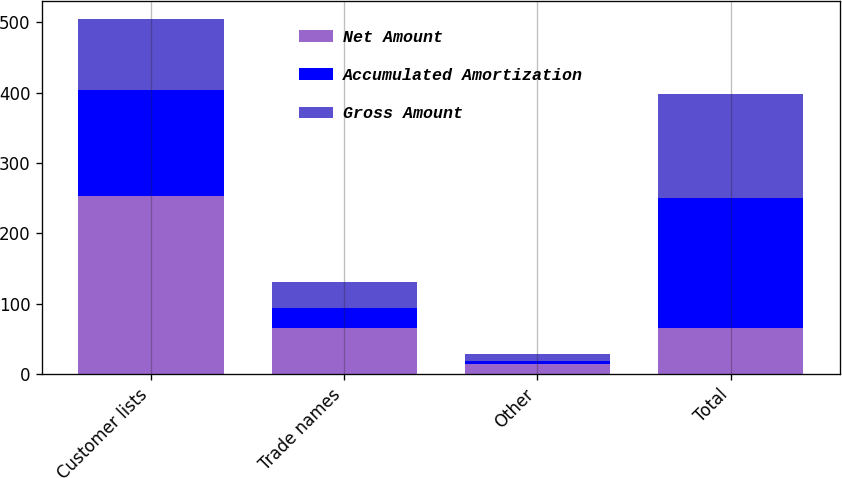<chart> <loc_0><loc_0><loc_500><loc_500><stacked_bar_chart><ecel><fcel>Customer lists<fcel>Trade names<fcel>Other<fcel>Total<nl><fcel>Net Amount<fcel>252.4<fcel>65.5<fcel>14.3<fcel>65.5<nl><fcel>Accumulated Amortization<fcel>151.4<fcel>28.9<fcel>3.8<fcel>184.1<nl><fcel>Gross Amount<fcel>101<fcel>36.6<fcel>10.5<fcel>148.1<nl></chart> 